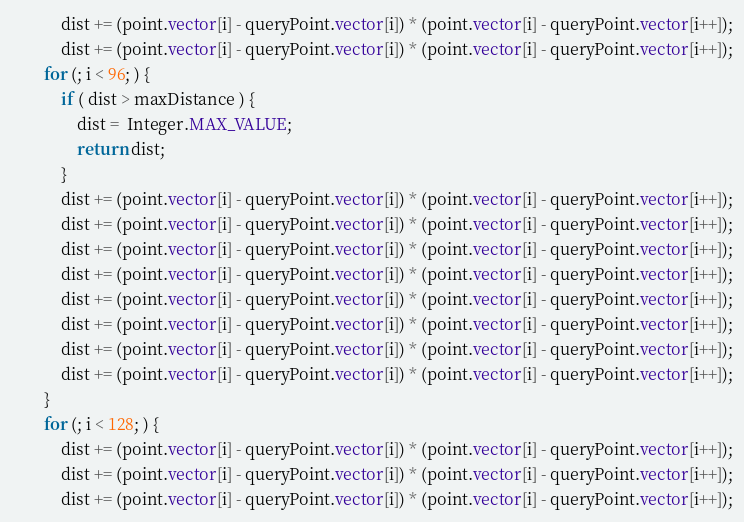<code> <loc_0><loc_0><loc_500><loc_500><_Java_>			dist += (point.vector[i] - queryPoint.vector[i]) * (point.vector[i] - queryPoint.vector[i++]);
			dist += (point.vector[i] - queryPoint.vector[i]) * (point.vector[i] - queryPoint.vector[i++]);
		for (; i < 96; ) {
			if ( dist > maxDistance ) {
				dist =  Integer.MAX_VALUE;
				return dist;
			}
			dist += (point.vector[i] - queryPoint.vector[i]) * (point.vector[i] - queryPoint.vector[i++]);
			dist += (point.vector[i] - queryPoint.vector[i]) * (point.vector[i] - queryPoint.vector[i++]);
			dist += (point.vector[i] - queryPoint.vector[i]) * (point.vector[i] - queryPoint.vector[i++]);
			dist += (point.vector[i] - queryPoint.vector[i]) * (point.vector[i] - queryPoint.vector[i++]);
			dist += (point.vector[i] - queryPoint.vector[i]) * (point.vector[i] - queryPoint.vector[i++]);
			dist += (point.vector[i] - queryPoint.vector[i]) * (point.vector[i] - queryPoint.vector[i++]);
			dist += (point.vector[i] - queryPoint.vector[i]) * (point.vector[i] - queryPoint.vector[i++]);
			dist += (point.vector[i] - queryPoint.vector[i]) * (point.vector[i] - queryPoint.vector[i++]);
		}
		for (; i < 128; ) {
			dist += (point.vector[i] - queryPoint.vector[i]) * (point.vector[i] - queryPoint.vector[i++]);
			dist += (point.vector[i] - queryPoint.vector[i]) * (point.vector[i] - queryPoint.vector[i++]);
			dist += (point.vector[i] - queryPoint.vector[i]) * (point.vector[i] - queryPoint.vector[i++]);</code> 